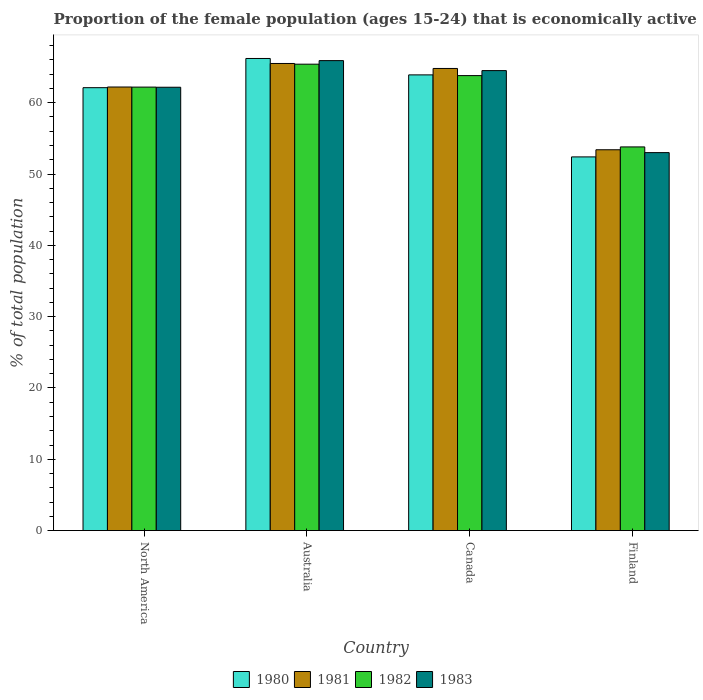How many different coloured bars are there?
Ensure brevity in your answer.  4. How many bars are there on the 4th tick from the right?
Your answer should be very brief. 4. In how many cases, is the number of bars for a given country not equal to the number of legend labels?
Provide a short and direct response. 0. What is the proportion of the female population that is economically active in 1983 in Australia?
Your response must be concise. 65.9. Across all countries, what is the maximum proportion of the female population that is economically active in 1980?
Offer a very short reply. 66.2. Across all countries, what is the minimum proportion of the female population that is economically active in 1983?
Provide a short and direct response. 53. In which country was the proportion of the female population that is economically active in 1983 maximum?
Ensure brevity in your answer.  Australia. What is the total proportion of the female population that is economically active in 1980 in the graph?
Your answer should be compact. 244.61. What is the difference between the proportion of the female population that is economically active in 1982 in Canada and that in Finland?
Keep it short and to the point. 10. What is the difference between the proportion of the female population that is economically active in 1982 in Australia and the proportion of the female population that is economically active in 1980 in Canada?
Your answer should be compact. 1.5. What is the average proportion of the female population that is economically active in 1983 per country?
Keep it short and to the point. 61.39. What is the difference between the proportion of the female population that is economically active of/in 1983 and proportion of the female population that is economically active of/in 1982 in Australia?
Your response must be concise. 0.5. What is the ratio of the proportion of the female population that is economically active in 1982 in Australia to that in Canada?
Ensure brevity in your answer.  1.03. Is the proportion of the female population that is economically active in 1980 in Canada less than that in North America?
Offer a very short reply. No. What is the difference between the highest and the second highest proportion of the female population that is economically active in 1981?
Keep it short and to the point. -0.7. What is the difference between the highest and the lowest proportion of the female population that is economically active in 1981?
Make the answer very short. 12.1. Is it the case that in every country, the sum of the proportion of the female population that is economically active in 1980 and proportion of the female population that is economically active in 1981 is greater than the sum of proportion of the female population that is economically active in 1982 and proportion of the female population that is economically active in 1983?
Offer a terse response. No. What does the 1st bar from the left in Canada represents?
Offer a terse response. 1980. What does the 2nd bar from the right in Canada represents?
Ensure brevity in your answer.  1982. What is the difference between two consecutive major ticks on the Y-axis?
Offer a terse response. 10. How many legend labels are there?
Offer a very short reply. 4. What is the title of the graph?
Your response must be concise. Proportion of the female population (ages 15-24) that is economically active. What is the label or title of the X-axis?
Keep it short and to the point. Country. What is the label or title of the Y-axis?
Give a very brief answer. % of total population. What is the % of total population in 1980 in North America?
Offer a terse response. 62.11. What is the % of total population of 1981 in North America?
Your answer should be compact. 62.2. What is the % of total population in 1982 in North America?
Make the answer very short. 62.19. What is the % of total population of 1983 in North America?
Give a very brief answer. 62.17. What is the % of total population of 1980 in Australia?
Keep it short and to the point. 66.2. What is the % of total population of 1981 in Australia?
Provide a short and direct response. 65.5. What is the % of total population in 1982 in Australia?
Offer a very short reply. 65.4. What is the % of total population in 1983 in Australia?
Offer a very short reply. 65.9. What is the % of total population in 1980 in Canada?
Provide a succinct answer. 63.9. What is the % of total population in 1981 in Canada?
Keep it short and to the point. 64.8. What is the % of total population in 1982 in Canada?
Provide a succinct answer. 63.8. What is the % of total population in 1983 in Canada?
Offer a very short reply. 64.5. What is the % of total population of 1980 in Finland?
Ensure brevity in your answer.  52.4. What is the % of total population of 1981 in Finland?
Your response must be concise. 53.4. What is the % of total population in 1982 in Finland?
Offer a very short reply. 53.8. What is the % of total population of 1983 in Finland?
Provide a succinct answer. 53. Across all countries, what is the maximum % of total population in 1980?
Your response must be concise. 66.2. Across all countries, what is the maximum % of total population of 1981?
Provide a succinct answer. 65.5. Across all countries, what is the maximum % of total population of 1982?
Your answer should be very brief. 65.4. Across all countries, what is the maximum % of total population of 1983?
Your response must be concise. 65.9. Across all countries, what is the minimum % of total population of 1980?
Make the answer very short. 52.4. Across all countries, what is the minimum % of total population in 1981?
Your answer should be very brief. 53.4. Across all countries, what is the minimum % of total population in 1982?
Make the answer very short. 53.8. What is the total % of total population in 1980 in the graph?
Your answer should be compact. 244.61. What is the total % of total population of 1981 in the graph?
Ensure brevity in your answer.  245.9. What is the total % of total population of 1982 in the graph?
Keep it short and to the point. 245.19. What is the total % of total population of 1983 in the graph?
Provide a short and direct response. 245.57. What is the difference between the % of total population in 1980 in North America and that in Australia?
Give a very brief answer. -4.09. What is the difference between the % of total population of 1981 in North America and that in Australia?
Provide a succinct answer. -3.3. What is the difference between the % of total population of 1982 in North America and that in Australia?
Ensure brevity in your answer.  -3.21. What is the difference between the % of total population of 1983 in North America and that in Australia?
Ensure brevity in your answer.  -3.73. What is the difference between the % of total population in 1980 in North America and that in Canada?
Your answer should be very brief. -1.79. What is the difference between the % of total population in 1981 in North America and that in Canada?
Give a very brief answer. -2.6. What is the difference between the % of total population in 1982 in North America and that in Canada?
Your answer should be compact. -1.61. What is the difference between the % of total population in 1983 in North America and that in Canada?
Offer a very short reply. -2.33. What is the difference between the % of total population in 1980 in North America and that in Finland?
Make the answer very short. 9.71. What is the difference between the % of total population in 1981 in North America and that in Finland?
Offer a very short reply. 8.8. What is the difference between the % of total population in 1982 in North America and that in Finland?
Provide a succinct answer. 8.39. What is the difference between the % of total population in 1983 in North America and that in Finland?
Offer a terse response. 9.17. What is the difference between the % of total population in 1982 in Australia and that in Canada?
Make the answer very short. 1.6. What is the difference between the % of total population in 1983 in Australia and that in Canada?
Provide a short and direct response. 1.4. What is the difference between the % of total population in 1980 in Australia and that in Finland?
Offer a very short reply. 13.8. What is the difference between the % of total population in 1981 in Australia and that in Finland?
Offer a terse response. 12.1. What is the difference between the % of total population of 1983 in Australia and that in Finland?
Your answer should be compact. 12.9. What is the difference between the % of total population of 1980 in Canada and that in Finland?
Provide a short and direct response. 11.5. What is the difference between the % of total population in 1981 in Canada and that in Finland?
Keep it short and to the point. 11.4. What is the difference between the % of total population of 1980 in North America and the % of total population of 1981 in Australia?
Your answer should be very brief. -3.39. What is the difference between the % of total population in 1980 in North America and the % of total population in 1982 in Australia?
Offer a terse response. -3.29. What is the difference between the % of total population in 1980 in North America and the % of total population in 1983 in Australia?
Offer a terse response. -3.79. What is the difference between the % of total population in 1981 in North America and the % of total population in 1982 in Australia?
Provide a succinct answer. -3.2. What is the difference between the % of total population of 1981 in North America and the % of total population of 1983 in Australia?
Offer a terse response. -3.7. What is the difference between the % of total population in 1982 in North America and the % of total population in 1983 in Australia?
Offer a terse response. -3.71. What is the difference between the % of total population of 1980 in North America and the % of total population of 1981 in Canada?
Provide a succinct answer. -2.69. What is the difference between the % of total population in 1980 in North America and the % of total population in 1982 in Canada?
Offer a terse response. -1.69. What is the difference between the % of total population of 1980 in North America and the % of total population of 1983 in Canada?
Offer a terse response. -2.39. What is the difference between the % of total population of 1981 in North America and the % of total population of 1982 in Canada?
Give a very brief answer. -1.6. What is the difference between the % of total population of 1981 in North America and the % of total population of 1983 in Canada?
Provide a succinct answer. -2.3. What is the difference between the % of total population in 1982 in North America and the % of total population in 1983 in Canada?
Your answer should be compact. -2.31. What is the difference between the % of total population in 1980 in North America and the % of total population in 1981 in Finland?
Offer a very short reply. 8.71. What is the difference between the % of total population in 1980 in North America and the % of total population in 1982 in Finland?
Provide a succinct answer. 8.31. What is the difference between the % of total population of 1980 in North America and the % of total population of 1983 in Finland?
Offer a terse response. 9.11. What is the difference between the % of total population of 1981 in North America and the % of total population of 1982 in Finland?
Provide a short and direct response. 8.4. What is the difference between the % of total population in 1981 in North America and the % of total population in 1983 in Finland?
Ensure brevity in your answer.  9.2. What is the difference between the % of total population of 1982 in North America and the % of total population of 1983 in Finland?
Your answer should be very brief. 9.19. What is the difference between the % of total population in 1980 in Australia and the % of total population in 1981 in Canada?
Make the answer very short. 1.4. What is the difference between the % of total population of 1980 in Australia and the % of total population of 1982 in Canada?
Provide a succinct answer. 2.4. What is the difference between the % of total population of 1980 in Australia and the % of total population of 1983 in Canada?
Offer a terse response. 1.7. What is the difference between the % of total population in 1981 in Australia and the % of total population in 1982 in Canada?
Your answer should be compact. 1.7. What is the difference between the % of total population in 1980 in Australia and the % of total population in 1982 in Finland?
Keep it short and to the point. 12.4. What is the difference between the % of total population of 1981 in Australia and the % of total population of 1983 in Finland?
Keep it short and to the point. 12.5. What is the difference between the % of total population in 1980 in Canada and the % of total population in 1981 in Finland?
Offer a terse response. 10.5. What is the average % of total population in 1980 per country?
Keep it short and to the point. 61.15. What is the average % of total population of 1981 per country?
Give a very brief answer. 61.47. What is the average % of total population of 1982 per country?
Ensure brevity in your answer.  61.3. What is the average % of total population in 1983 per country?
Your response must be concise. 61.39. What is the difference between the % of total population in 1980 and % of total population in 1981 in North America?
Your answer should be very brief. -0.09. What is the difference between the % of total population in 1980 and % of total population in 1982 in North America?
Provide a short and direct response. -0.08. What is the difference between the % of total population in 1980 and % of total population in 1983 in North America?
Ensure brevity in your answer.  -0.06. What is the difference between the % of total population of 1981 and % of total population of 1982 in North America?
Offer a terse response. 0.01. What is the difference between the % of total population in 1981 and % of total population in 1983 in North America?
Make the answer very short. 0.03. What is the difference between the % of total population in 1982 and % of total population in 1983 in North America?
Your answer should be very brief. 0.02. What is the difference between the % of total population of 1980 and % of total population of 1981 in Australia?
Make the answer very short. 0.7. What is the difference between the % of total population of 1980 and % of total population of 1982 in Australia?
Your answer should be compact. 0.8. What is the difference between the % of total population in 1980 and % of total population in 1983 in Australia?
Keep it short and to the point. 0.3. What is the difference between the % of total population in 1980 and % of total population in 1981 in Canada?
Your answer should be compact. -0.9. What is the difference between the % of total population in 1980 and % of total population in 1982 in Canada?
Give a very brief answer. 0.1. What is the difference between the % of total population of 1980 and % of total population of 1982 in Finland?
Provide a succinct answer. -1.4. What is the difference between the % of total population of 1980 and % of total population of 1983 in Finland?
Your answer should be very brief. -0.6. What is the difference between the % of total population in 1981 and % of total population in 1982 in Finland?
Your response must be concise. -0.4. What is the ratio of the % of total population of 1980 in North America to that in Australia?
Your answer should be compact. 0.94. What is the ratio of the % of total population of 1981 in North America to that in Australia?
Keep it short and to the point. 0.95. What is the ratio of the % of total population in 1982 in North America to that in Australia?
Offer a terse response. 0.95. What is the ratio of the % of total population of 1983 in North America to that in Australia?
Provide a short and direct response. 0.94. What is the ratio of the % of total population of 1980 in North America to that in Canada?
Provide a succinct answer. 0.97. What is the ratio of the % of total population in 1981 in North America to that in Canada?
Your response must be concise. 0.96. What is the ratio of the % of total population of 1982 in North America to that in Canada?
Ensure brevity in your answer.  0.97. What is the ratio of the % of total population in 1983 in North America to that in Canada?
Give a very brief answer. 0.96. What is the ratio of the % of total population in 1980 in North America to that in Finland?
Your response must be concise. 1.19. What is the ratio of the % of total population of 1981 in North America to that in Finland?
Your response must be concise. 1.16. What is the ratio of the % of total population of 1982 in North America to that in Finland?
Your answer should be very brief. 1.16. What is the ratio of the % of total population in 1983 in North America to that in Finland?
Ensure brevity in your answer.  1.17. What is the ratio of the % of total population of 1980 in Australia to that in Canada?
Offer a terse response. 1.04. What is the ratio of the % of total population of 1981 in Australia to that in Canada?
Your answer should be very brief. 1.01. What is the ratio of the % of total population in 1982 in Australia to that in Canada?
Offer a terse response. 1.03. What is the ratio of the % of total population in 1983 in Australia to that in Canada?
Make the answer very short. 1.02. What is the ratio of the % of total population of 1980 in Australia to that in Finland?
Offer a very short reply. 1.26. What is the ratio of the % of total population of 1981 in Australia to that in Finland?
Your response must be concise. 1.23. What is the ratio of the % of total population in 1982 in Australia to that in Finland?
Provide a succinct answer. 1.22. What is the ratio of the % of total population in 1983 in Australia to that in Finland?
Give a very brief answer. 1.24. What is the ratio of the % of total population of 1980 in Canada to that in Finland?
Give a very brief answer. 1.22. What is the ratio of the % of total population in 1981 in Canada to that in Finland?
Make the answer very short. 1.21. What is the ratio of the % of total population in 1982 in Canada to that in Finland?
Your answer should be very brief. 1.19. What is the ratio of the % of total population of 1983 in Canada to that in Finland?
Make the answer very short. 1.22. What is the difference between the highest and the second highest % of total population of 1981?
Provide a succinct answer. 0.7. What is the difference between the highest and the lowest % of total population of 1982?
Provide a succinct answer. 11.6. What is the difference between the highest and the lowest % of total population in 1983?
Ensure brevity in your answer.  12.9. 